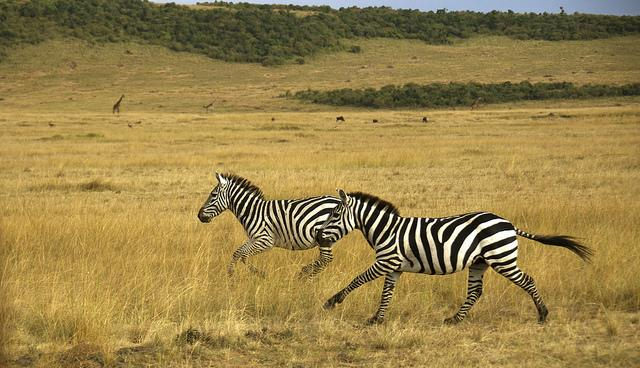How many zebras are running across the savannah plain? Please explain your reasoning. two. There are 2. 